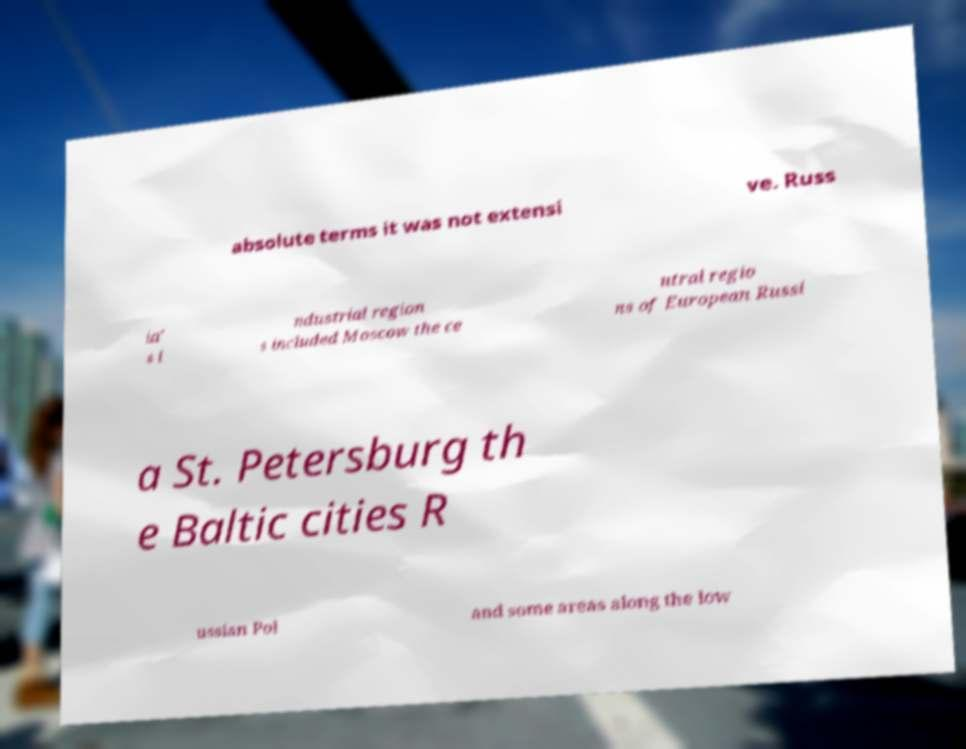Can you read and provide the text displayed in the image?This photo seems to have some interesting text. Can you extract and type it out for me? absolute terms it was not extensi ve. Russ ia' s i ndustrial region s included Moscow the ce ntral regio ns of European Russi a St. Petersburg th e Baltic cities R ussian Pol and some areas along the low 